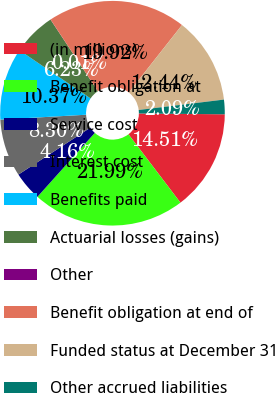Convert chart to OTSL. <chart><loc_0><loc_0><loc_500><loc_500><pie_chart><fcel>(in millions)<fcel>Benefit obligation at<fcel>Service cost<fcel>Interest cost<fcel>Benefits paid<fcel>Actuarial losses (gains)<fcel>Other<fcel>Benefit obligation at end of<fcel>Funded status at December 31<fcel>Other accrued liabilities<nl><fcel>14.51%<fcel>21.99%<fcel>4.16%<fcel>8.3%<fcel>10.37%<fcel>6.23%<fcel>0.01%<fcel>19.92%<fcel>12.44%<fcel>2.09%<nl></chart> 